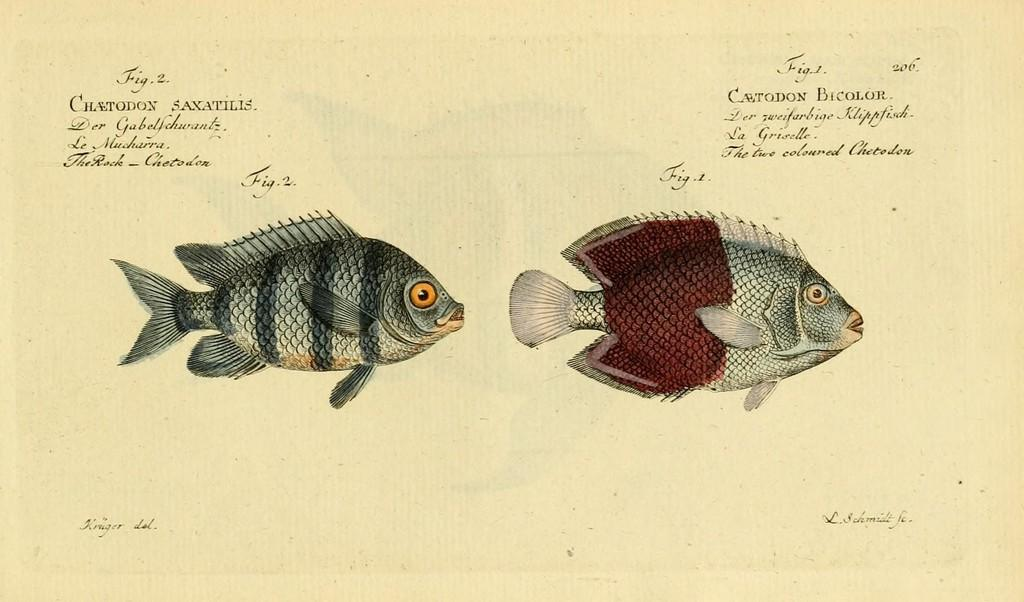What is the main subject of the image? The main subject of the image is a paper. What is depicted on the paper? The paper has fishes depicted on it. Are there any words or symbols on the paper? Yes, there is text on the paper. What is the weather like in the image? The provided facts do not mention any information about the weather, so it cannot be determined from the image. How many beds are visible in the image? There are no beds present in the image; it features a paper with fishes and text. 